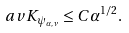<formula> <loc_0><loc_0><loc_500><loc_500>\ a v { K } _ { \psi _ { \alpha , \nu } } \leq C \alpha ^ { 1 / 2 } .</formula> 